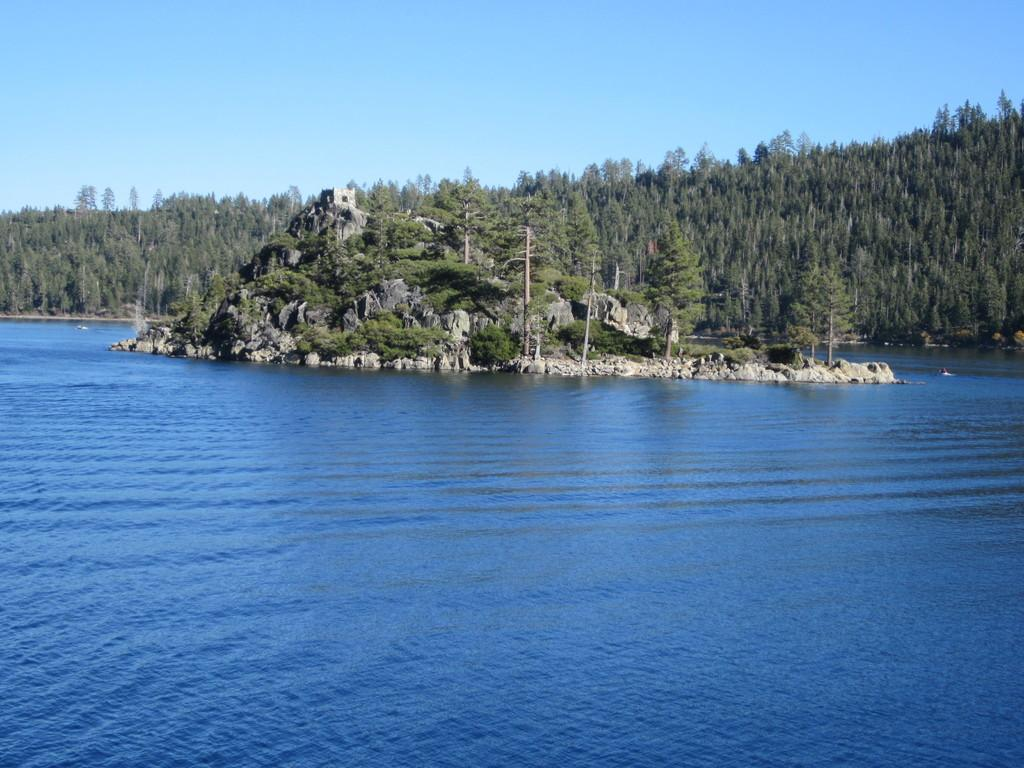What is the primary color of the water in the image? The water in the image is blue. What is located in the water? There is an island in the water. What features can be seen on the island? The island has rock hills, plants, and trees. What can be seen in the background of the image? There are hills with trees and the sky visible in the background. What type of rice is being cooked on the island in the image? There is no rice present in the image; it features an island with rock hills, plants, and trees. What color is the suit worn by the trees in the image? There are no suits or people in the image; it features an island with rock hills, plants, and trees. 